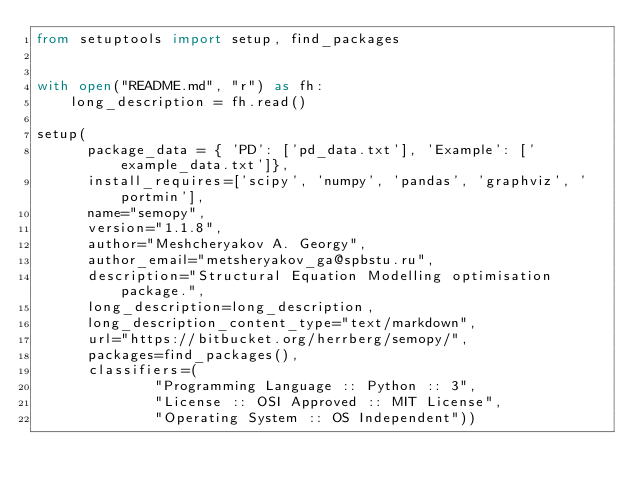<code> <loc_0><loc_0><loc_500><loc_500><_Python_>from setuptools import setup, find_packages


with open("README.md", "r") as fh:
    long_description = fh.read()

setup(
      package_data = { 'PD': ['pd_data.txt'], 'Example': ['example_data.txt']},
      install_requires=['scipy', 'numpy', 'pandas', 'graphviz', 'portmin'],
      name="semopy",
      version="1.1.8",
      author="Meshcheryakov A. Georgy",
      author_email="metsheryakov_ga@spbstu.ru",
      description="Structural Equation Modelling optimisation package.",
      long_description=long_description,
      long_description_content_type="text/markdown",
      url="https://bitbucket.org/herrberg/semopy/",
      packages=find_packages(),
      classifiers=(
              "Programming Language :: Python :: 3",
              "License :: OSI Approved :: MIT License",
              "Operating System :: OS Independent"))
</code> 